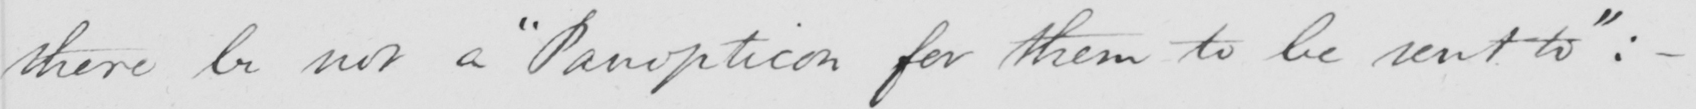What is written in this line of handwriting? there be not a "Panopticon for them to be sent to": _ 